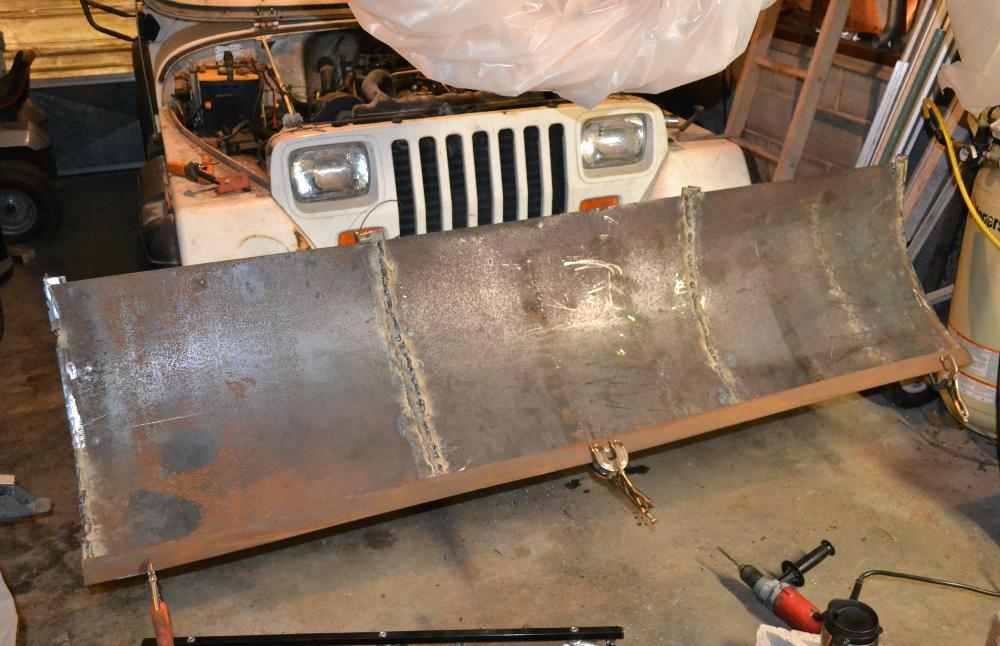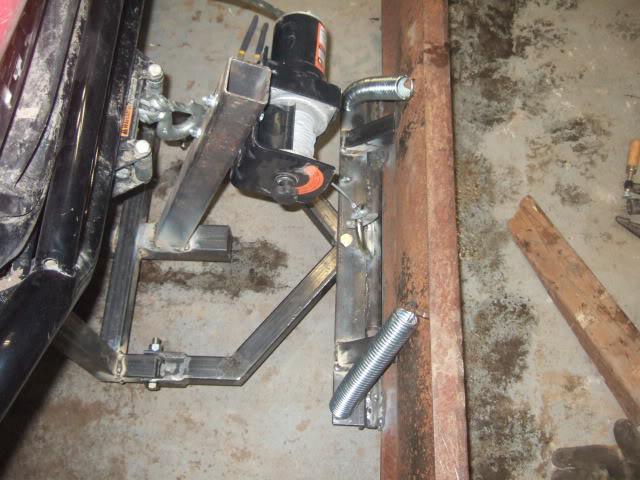The first image is the image on the left, the second image is the image on the right. Given the left and right images, does the statement "At least one tire is visible in one of the images." hold true? Answer yes or no. No. The first image is the image on the left, the second image is the image on the right. Given the left and right images, does the statement "An image shows an attached snow plow on a snow-covered ground." hold true? Answer yes or no. No. 